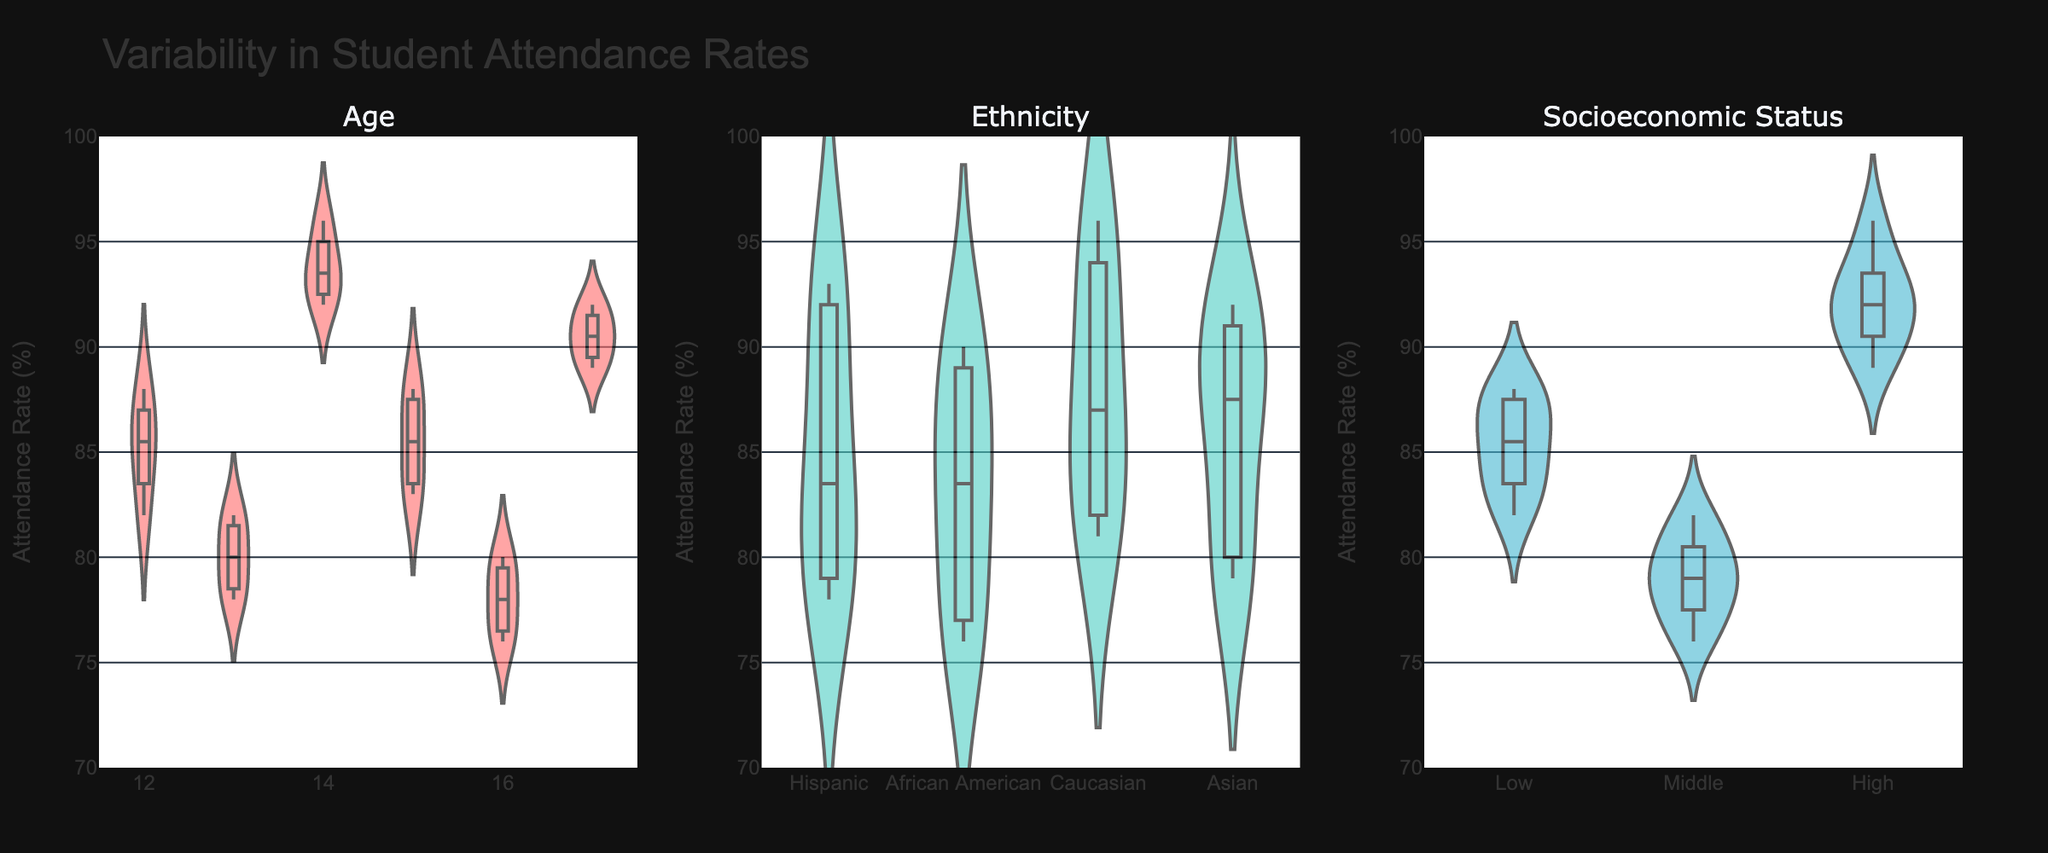What is the title of the figure? The title of the figure is displayed prominently at the top of the plot. It reads "Variability in Student Attendance Rates".
Answer: Variability in Student Attendance Rates What colors are used for the violin plots? The figure uses three different colors for the violin plots. The Age violin plot is filled with a pinkish-red color, the Ethnicity plot with a teal color, and the Socioeconomic Status plot with a turquoise color.
Answer: Pinkish-red, Teal, Turquoise Which demographic group appears to have the highest variability in attendance rates? By looking at the spread and distribution of the violin plots, you can see which group has the most variation. The Age group has the broadest spread and numerous peaks and valleys in its violin plot, indicating the highest variability.
Answer: Age What is the attendance rate range for the Ethnicity violin plot? The y-axis represents attendance rates and ranges from 70 to 100%. The Ethnicity violin plot spans almost the entire range, with most data points falling between approximately 76% and 96%.
Answer: 76% - 96% Which socioeconomic status group has the highest median attendance rate? The violin plot for Socioeconomic Status includes box plots which display the median attendance rate as a horizontal line within each group. The "High" socioeconomic status group has the highest median, noticeably higher than the "Low" and "Middle" groups.
Answer: High Compare the attendance rates of 12- and 17-year-olds. Which has the higher average attendance rate? Looking at the Age violin plot, the 12-year-olds have attendance rates clustered around the 83% mark, while the 17-year-olds have a tighter cluster around the 91% mark. So, 17-year-olds have the higher average.
Answer: 17-year-olds Among the ethnic groups, which has the lowest variability in attendance rates? By examining the distribution of each ethnicity in the Ethnicity violin plot, Caucasian students show a narrower spread compared to the other ethnic groups, indicating lower variability.
Answer: Caucasian Are there more data points in the Middle socioeconomic status group or the Low socioeconomic status group? Looking closely at the Socioeconomic Status violin plot, we observe the thickness and density of the distributions for the "Middle" and "Low" groups. The "Middle" group seems to have denser clusters, suggesting more data points.
Answer: Middle What is the difference in attendance rates between the highest point in the Age violin plot and the lowest point in the Socioeconomic Status violin plot? The highest point in the Age plot appears around 96%, and the lowest in the Socioeconomic Status plot is around 76%. The difference between these two extremes is 96% - 76% = 20%.
Answer: 20% Which ethnic group has an attendance rate closest to 90% in the violin plot? Examining the Ethnicity violin plot, the Asian group has data points most closely clustered around the 90% mark.
Answer: Asian 